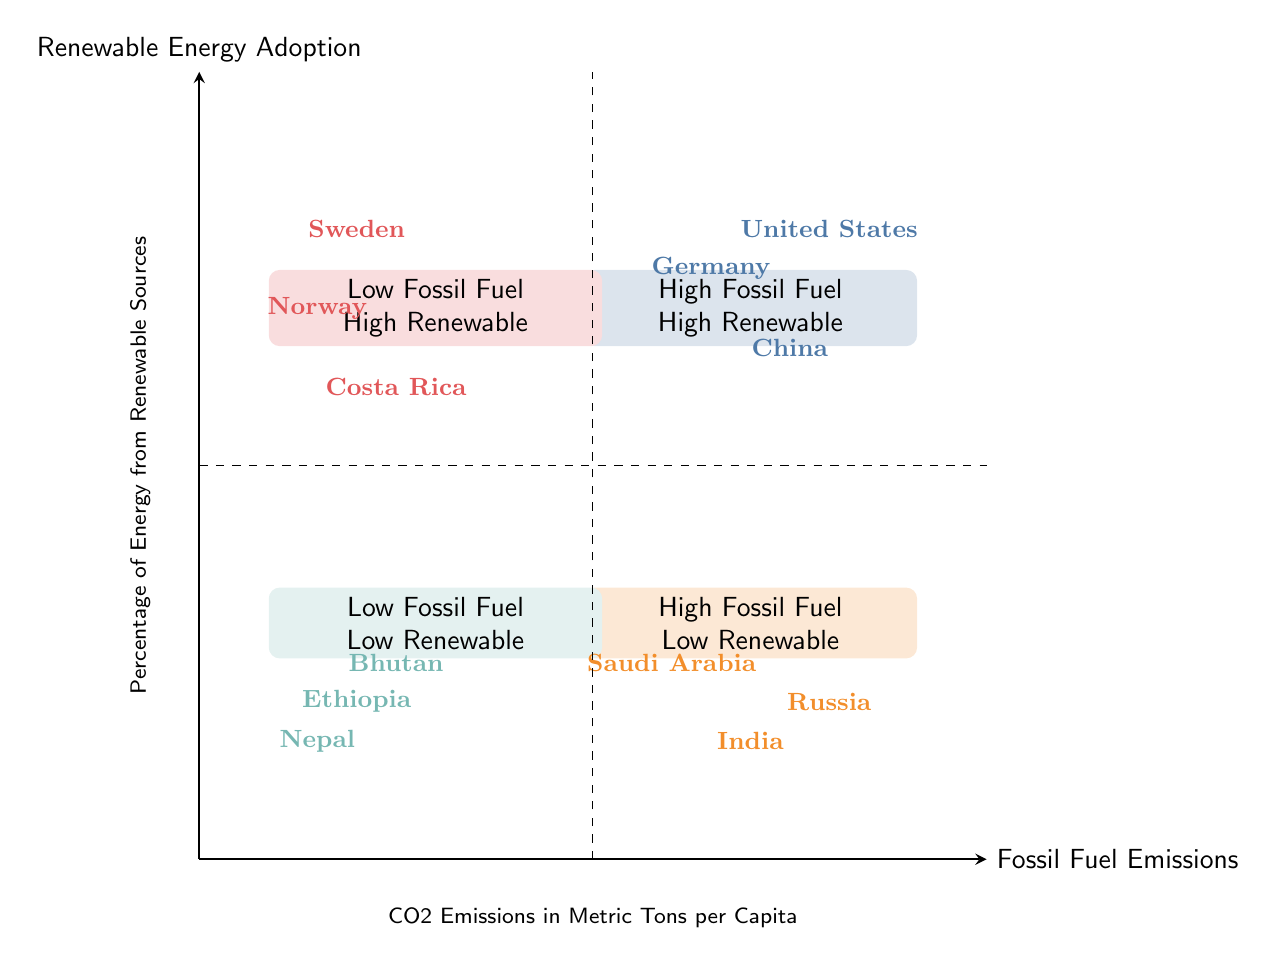What is the region with the highest fossil fuel emissions and high renewable energy adoption? From the quadrant labeled "High Fossil Fuel High Renewable," the diagram lists the United States, China, and Germany as examples. Since the question specifies the region with the highest fossil fuel emissions, we can infer that the United States is typically recognized for having the highest emissions among these examples.
Answer: United States Which region has low fossil fuel emissions and high renewable energy adoption? The quadrant labeled "Low Fossil Fuel High Renewable" includes Sweden, Norway, and Costa Rica. In this case, we simply identify the region mentioned in that quadrant.
Answer: Sweden How many regions fall into the category of high fossil fuel emissions and low renewable energy adoption? Looking at the "High Fossil Fuel Low Renewable" quadrant, we observe that it contains three examples: Russia, India, and Saudi Arabia. Thus, we can state that the count of regions is three.
Answer: Three What is the relationship between fossil fuel emissions and renewable energy adoption in "Low Fossil Fuel Low Renewable" regions? By examining the quadrant labeled "Low Fossil Fuel Low Renewable," this grouping indicates that these regions have both low fossil fuel emissions and low renewable energy adoption. Therefore, the relationship can be summarized as both factors being low.
Answer: Low Which country is an example of a region with high fossil fuel emissions but low renewable energy adoption? Referring to the "High Fossil Fuel Low Renewable" quadrant, Russia is listed as one of the countries that fits this criterion.
Answer: Russia How many examples are provided for low fossil fuel and low renewable energy adoption? The quadrant "Low Fossil Fuel Low Renewable" presents three examples: Ethiopia, Nepal, and Bhutan. Therefore, we assess the number of examples to be three.
Answer: Three What distinguishes the "High Fossil Fuel High Renewable" quadrant from the "High Fossil Fuel Low Renewable" quadrant? The distinction lies in the level of renewable energy adoption; the "High Fossil Fuel High Renewable" quadrant includes regions with high fossil fuel emissions and significant renewable energy adoption, while the "High Fossil Fuel Low Renewable" quadrant has high emissions but low renewable adoption.
Answer: Level of renewable energy adoption Which country among the listed examples has a reputation for significant renewable energy utilization? In the "Low Fossil Fuel High Renewable" quadrant, countries such as Sweden, Norway, and Costa Rica are identified as regions with high renewable energy adoption. Among these, Costa Rica is particularly known for its significant renewable energy utilization due to its extensive use of hydroelectric power.
Answer: Costa Rica 